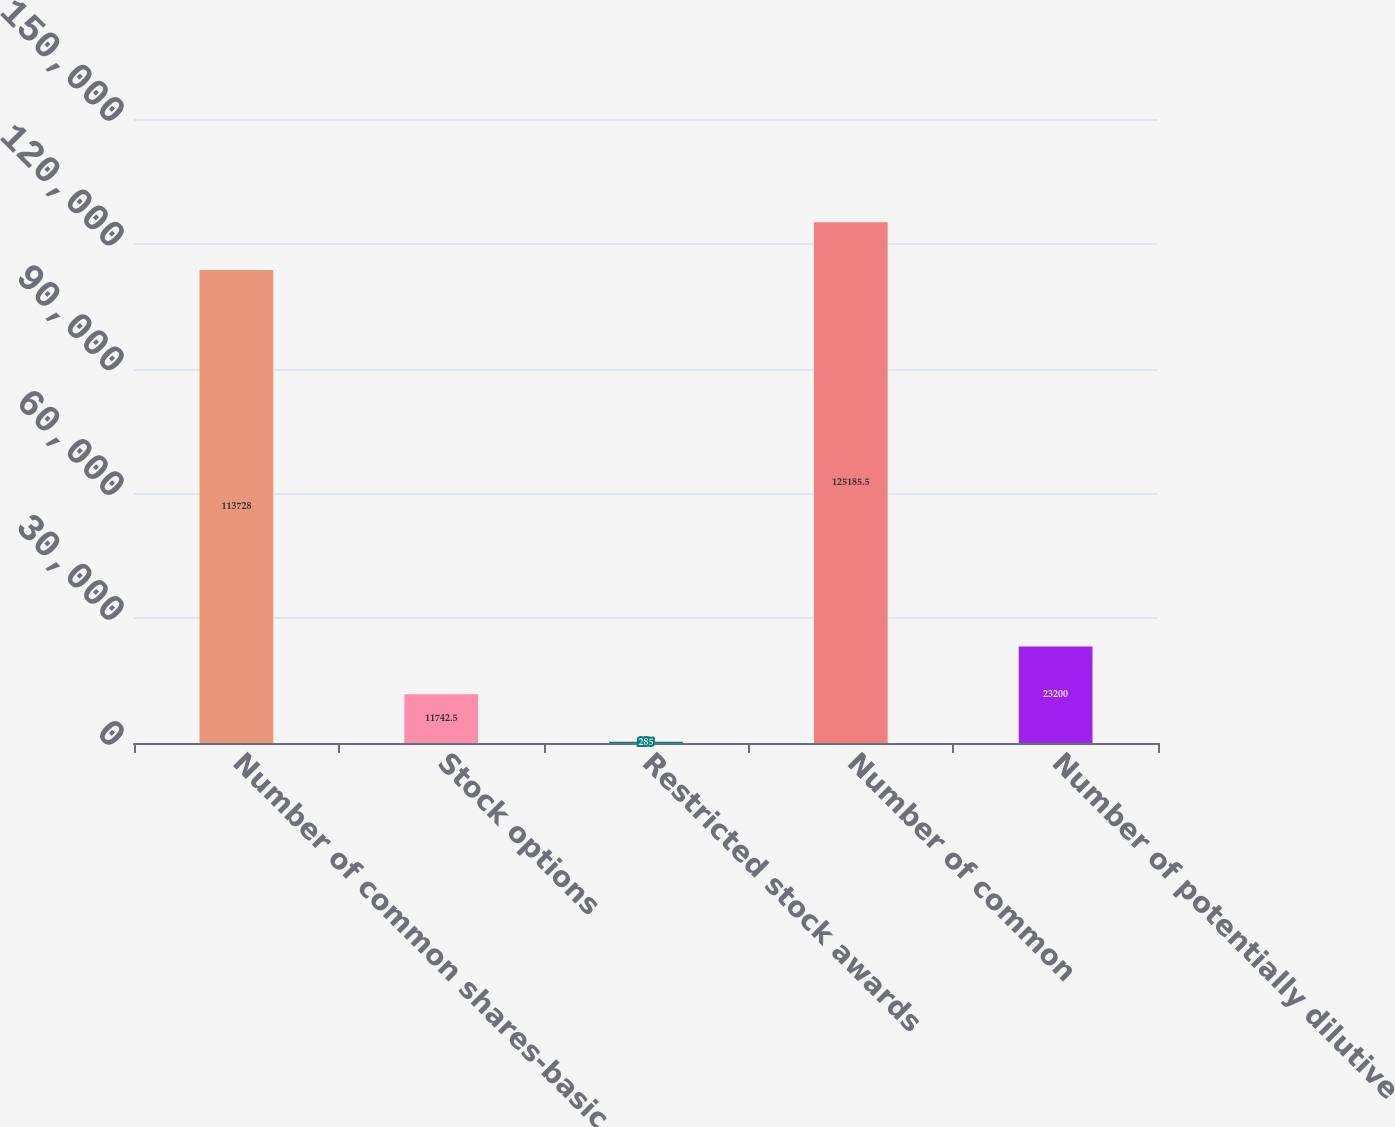Convert chart. <chart><loc_0><loc_0><loc_500><loc_500><bar_chart><fcel>Number of common shares-basic<fcel>Stock options<fcel>Restricted stock awards<fcel>Number of common<fcel>Number of potentially dilutive<nl><fcel>113728<fcel>11742.5<fcel>285<fcel>125186<fcel>23200<nl></chart> 